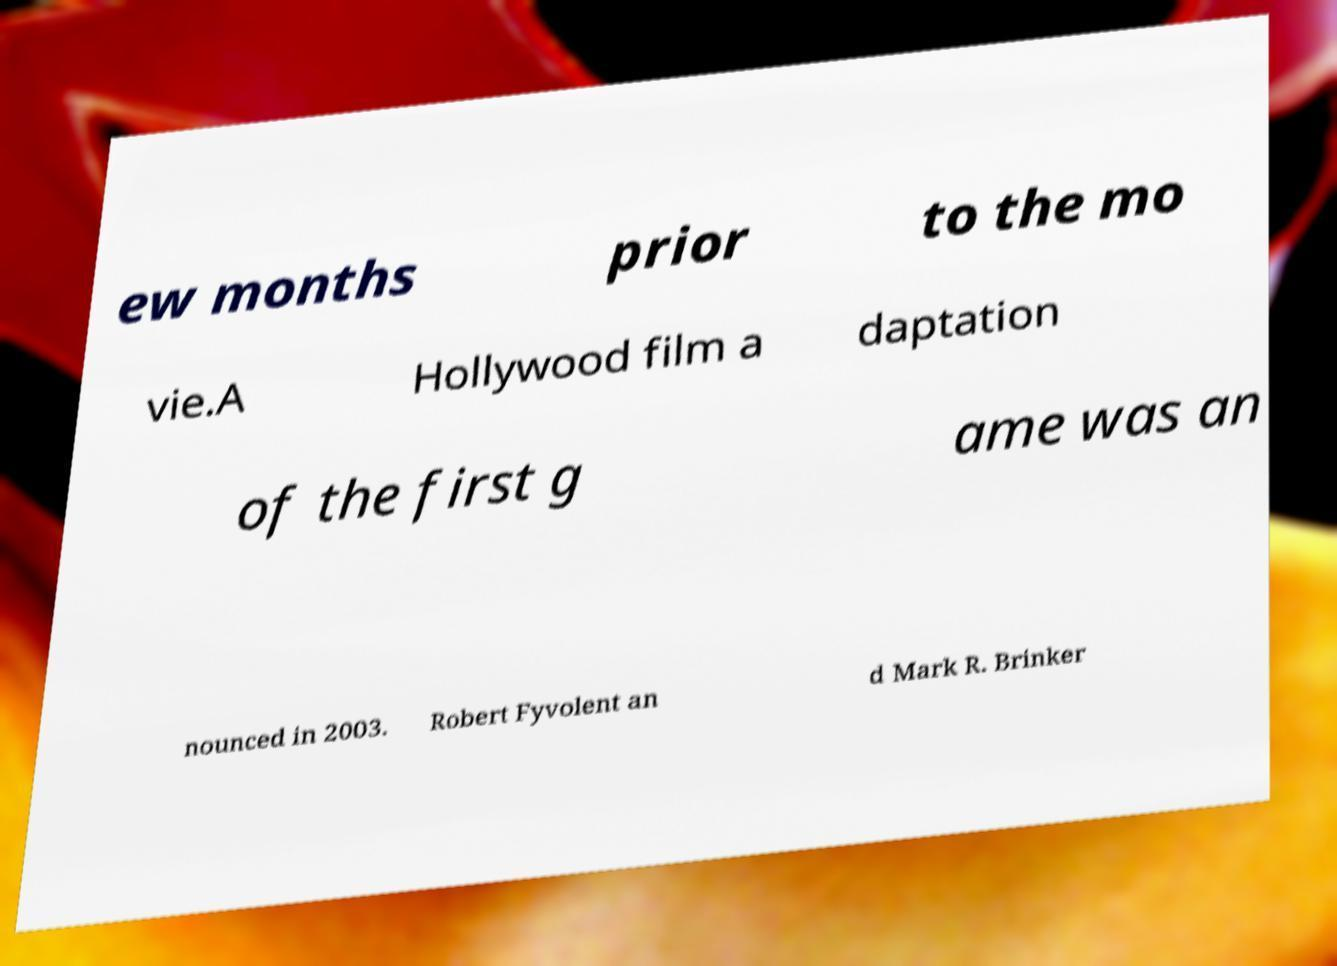I need the written content from this picture converted into text. Can you do that? ew months prior to the mo vie.A Hollywood film a daptation of the first g ame was an nounced in 2003. Robert Fyvolent an d Mark R. Brinker 